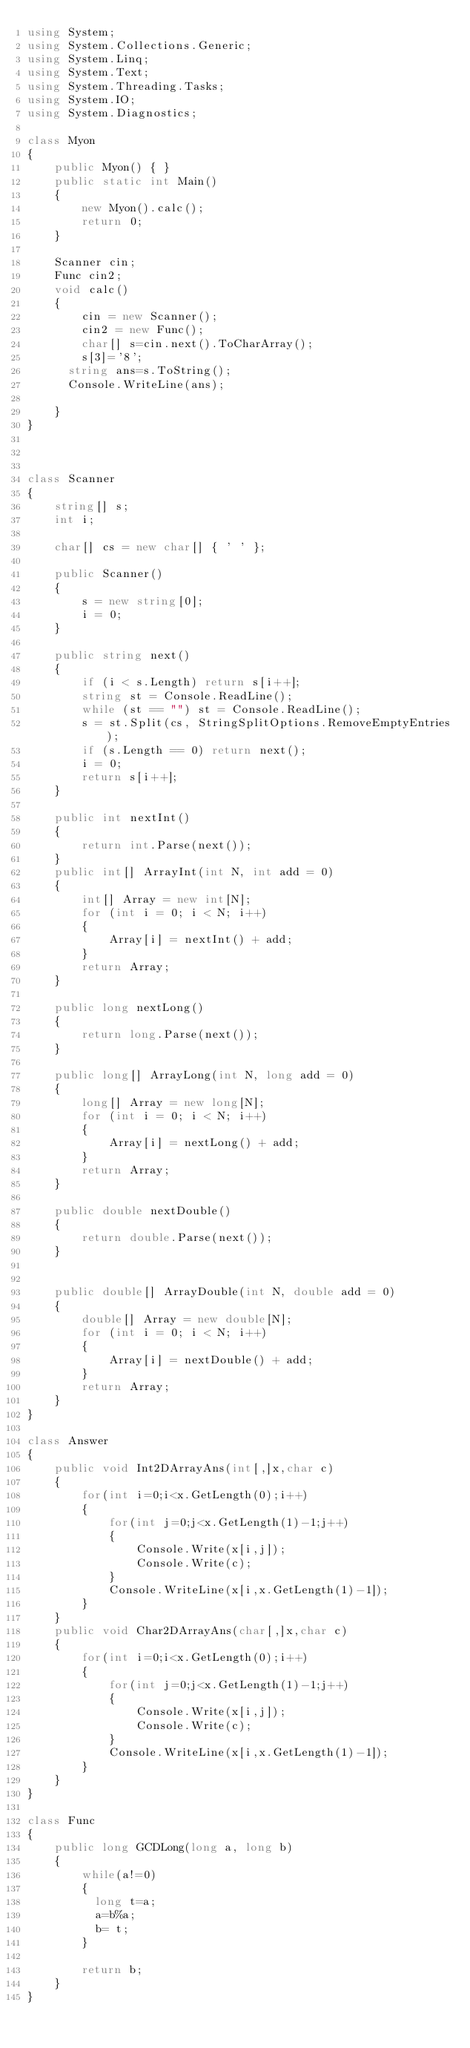Convert code to text. <code><loc_0><loc_0><loc_500><loc_500><_C#_>using System;
using System.Collections.Generic;
using System.Linq;
using System.Text;
using System.Threading.Tasks;
using System.IO;
using System.Diagnostics;

class Myon
{
    public Myon() { }
    public static int Main()
    {
        new Myon().calc();
        return 0;
    }

    Scanner cin;
    Func cin2;
    void calc()
    {
        cin = new Scanner();
        cin2 = new Func();
        char[] s=cin.next().ToCharArray();
        s[3]='8';
      string ans=s.ToString();
      Console.WriteLine(ans);
        
    }
}



class Scanner
{
    string[] s;
    int i;

    char[] cs = new char[] { ' ' };

    public Scanner()
    {
        s = new string[0];
        i = 0;
    }

    public string next()
    {
        if (i < s.Length) return s[i++];
        string st = Console.ReadLine();
        while (st == "") st = Console.ReadLine();
        s = st.Split(cs, StringSplitOptions.RemoveEmptyEntries);
        if (s.Length == 0) return next();
        i = 0;
        return s[i++];
    }

    public int nextInt()
    {
        return int.Parse(next());
    }
    public int[] ArrayInt(int N, int add = 0)
    {
        int[] Array = new int[N];
        for (int i = 0; i < N; i++)
        {
            Array[i] = nextInt() + add;
        }
        return Array;
    }

    public long nextLong()
    {
        return long.Parse(next());
    }

    public long[] ArrayLong(int N, long add = 0)
    {
        long[] Array = new long[N];
        for (int i = 0; i < N; i++)
        {
            Array[i] = nextLong() + add;
        }
        return Array;
    }

    public double nextDouble()
    {
        return double.Parse(next());
    }


    public double[] ArrayDouble(int N, double add = 0)
    {
        double[] Array = new double[N];
        for (int i = 0; i < N; i++)
        {
            Array[i] = nextDouble() + add;
        }
        return Array;
    }
}

class Answer
{
    public void Int2DArrayAns(int[,]x,char c)
    {
        for(int i=0;i<x.GetLength(0);i++)
        {
            for(int j=0;j<x.GetLength(1)-1;j++)
            {
                Console.Write(x[i,j]);
                Console.Write(c);
            }
            Console.WriteLine(x[i,x.GetLength(1)-1]);
        }
    }
    public void Char2DArrayAns(char[,]x,char c)
    {
        for(int i=0;i<x.GetLength(0);i++)
        {
            for(int j=0;j<x.GetLength(1)-1;j++)
            {
                Console.Write(x[i,j]);
                Console.Write(c);
            }
            Console.WriteLine(x[i,x.GetLength(1)-1]);
        }
    }
}

class Func
{
    public long GCDLong(long a, long b)
    {
        while(a!=0)
        {
          long t=a;
          a=b%a;
          b= t;
        }
      
        return b;        
    }
}</code> 